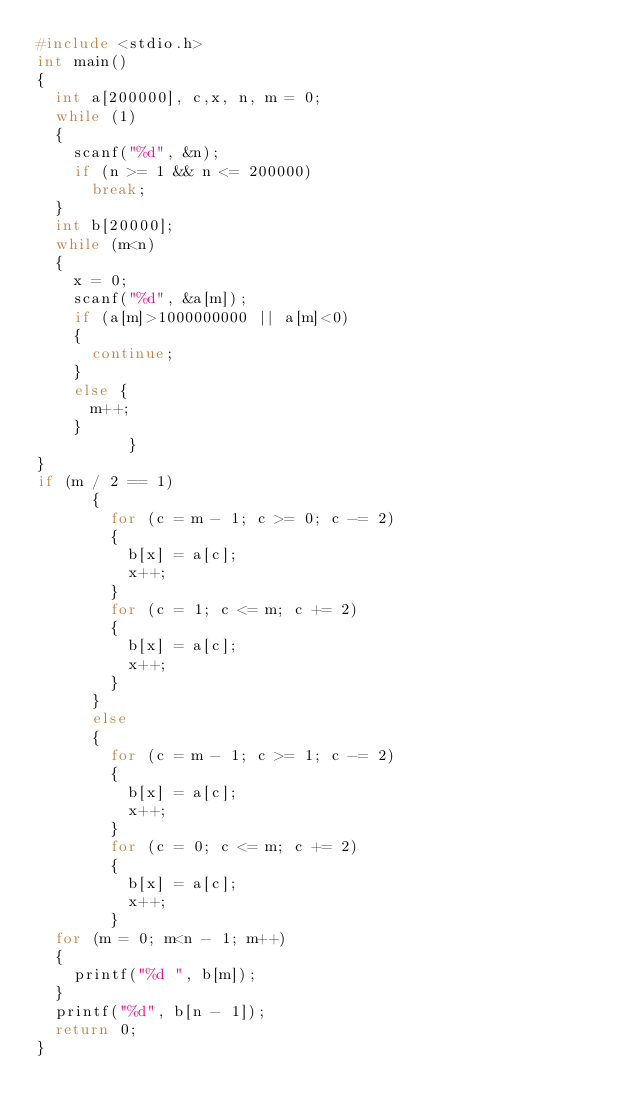Convert code to text. <code><loc_0><loc_0><loc_500><loc_500><_C_>#include <stdio.h>
int main()
{
	int a[200000], c,x, n, m = 0;
	while (1)
	{
		scanf("%d", &n);
		if (n >= 1 && n <= 200000)
			break;
	}
	int b[20000];
	while (m<n)
	{
		x = 0;
		scanf("%d", &a[m]);
		if (a[m]>1000000000 || a[m]<0)
		{
			continue;
		}
		else {
			m++;
		}
          }
}
if (m / 2 == 1)
			{
				for (c = m - 1; c >= 0; c -= 2)
				{
					b[x] = a[c];
					x++;
				}
				for (c = 1; c <= m; c += 2)
				{
					b[x] = a[c];
					x++;
				}
			}
			else
			{
				for (c = m - 1; c >= 1; c -= 2)
				{
					b[x] = a[c];
					x++;
				}
				for (c = 0; c <= m; c += 2)
				{
					b[x] = a[c];
					x++;
				}
	for (m = 0; m<n - 1; m++)
	{
		printf("%d ", b[m]);
	}
	printf("%d", b[n - 1]);
	return 0;
}</code> 